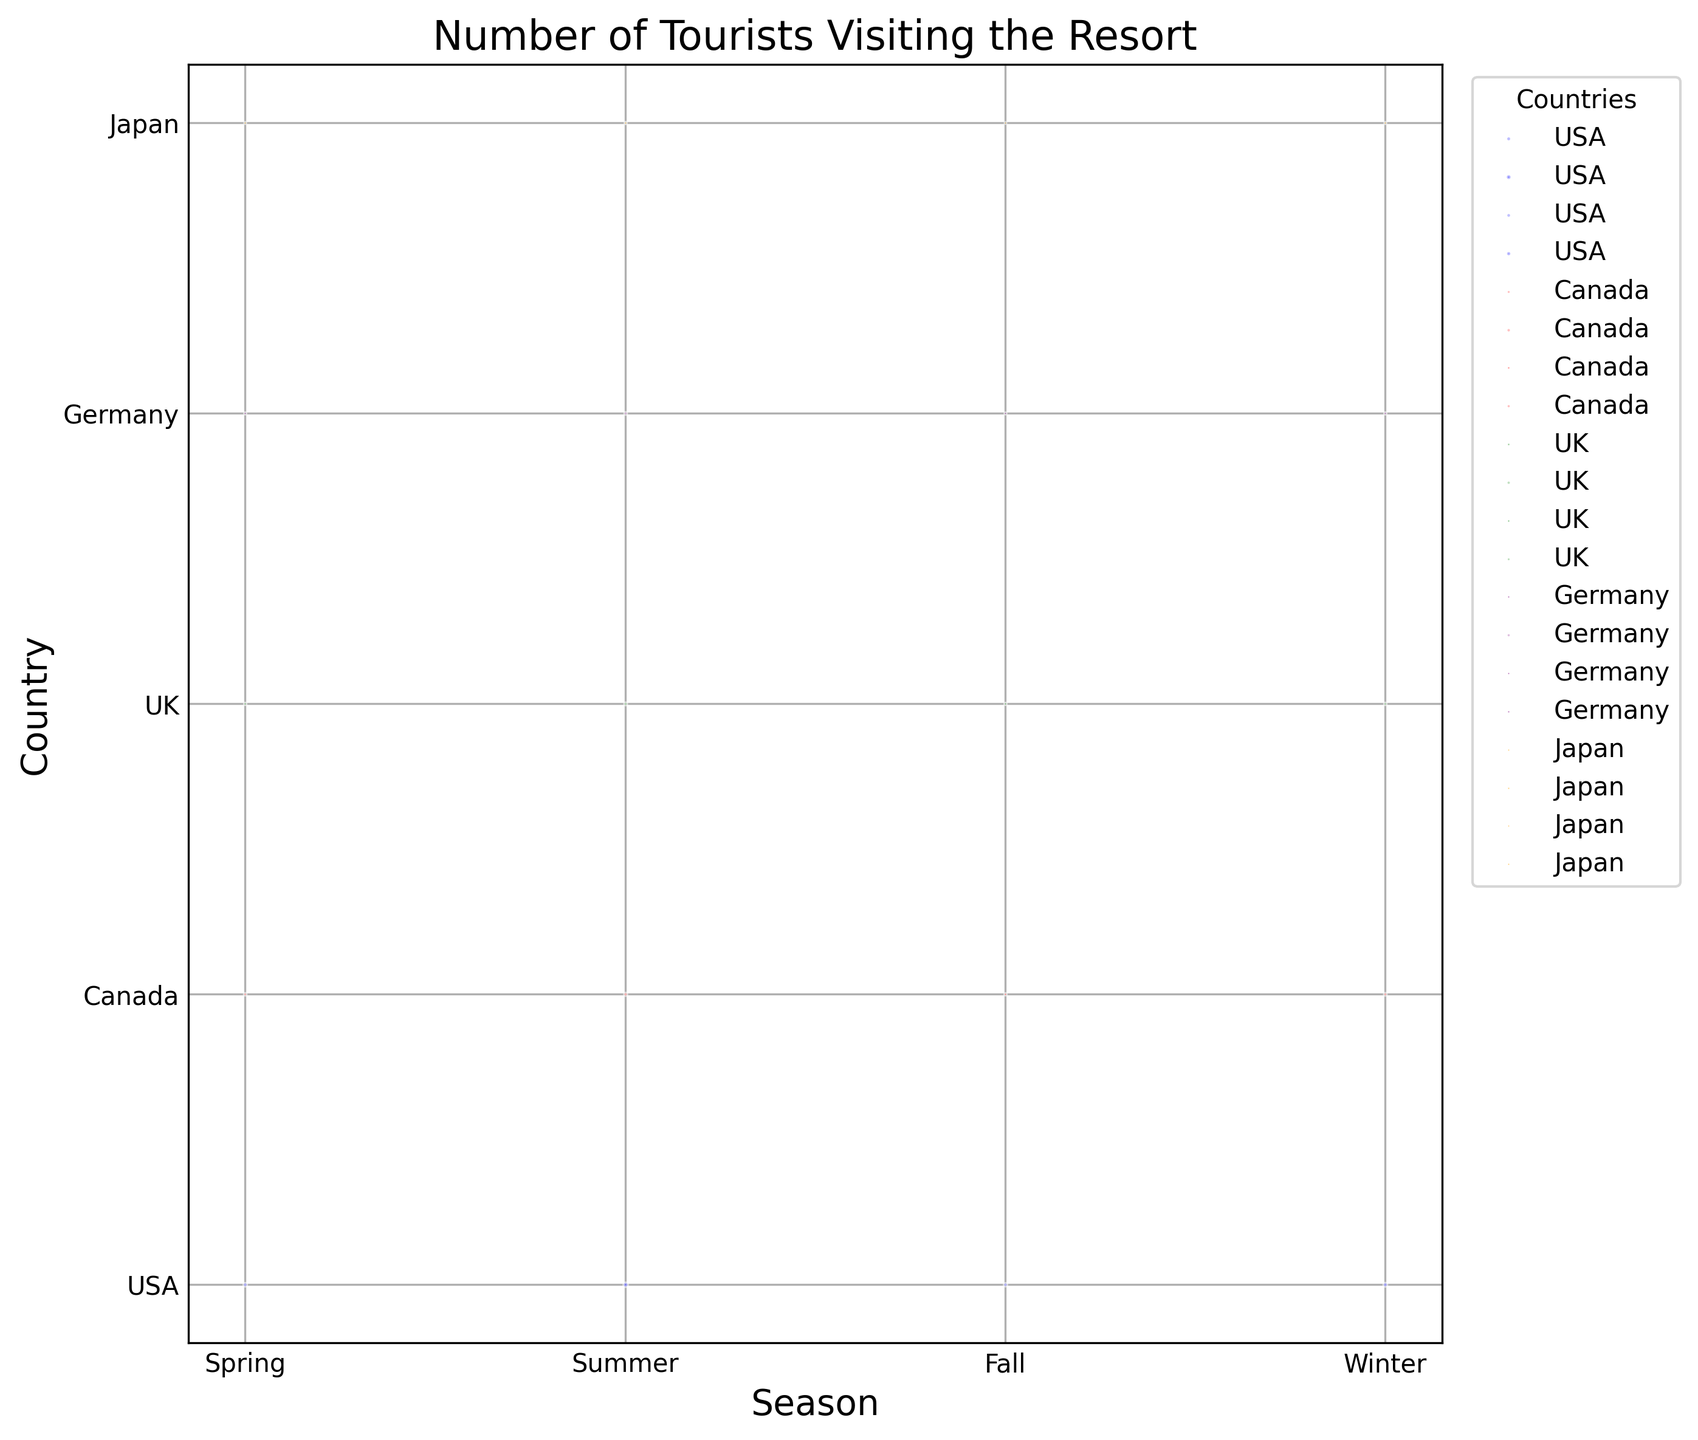How many tourists visited from Canada in the Spring? The figure shows the number of tourists by season and country. Locate Spring and find the bubble for Canada, which indicates 670 tourists.
Answer: 670 Which season did the USA have the highest number of tourists? Look for the largest bubble for the USA. The largest bubble is in the Summer.
Answer: Summer Compare the number of tourists from Japan in Winter and Fall. Which is higher? Find the bubbles for Japan in Winter and Fall. The bubble in Winter is larger with 350 tourists versus 210 tourists in Fall.
Answer: Winter Which country had the least number of tourists in Fall? Observe the size of bubbles for all countries in Fall. The smallest bubble is for Japan with 210 tourists.
Answer: Japan What is the total number of tourists from the UK across all seasons? Add the number of tourists from the UK in all seasons: 540 (Spring) + 880 (Summer) + 470 (Fall) + 620 (Winter) = 2510
Answer: 2510 How did the number of tourists from Germany change from Winter to Spring? Compare the number of tourists from Germany in Winter (510) and Spring (420). The change is 510 - 420 = 90 fewer tourists.
Answer: Decreased by 90 Among the listed seasons, which country had the second highest number of tourists in Summer? Find the countries in Summer and locate the second largest bubble. The USA has the highest (2300) and Canada the second highest (1020).
Answer: Canada Find the average number of tourists from Japan over all seasons. Calculate the average: (290 (Spring) + 460 (Summer) + 210 (Fall) + 350 (Winter)) / 4 = 1310 / 4 = 327.5
Answer: 327.5 Which two countries had the closest number of tourists in Spring, and what is the difference? Compare the number of tourists in Spring: USA (1450), Canada (670), UK (540), Germany (420), Japan (290). The UK and Germany have the closest numbers with a difference of 540 - 420 = 120.
Answer: UK and Germany, 120 